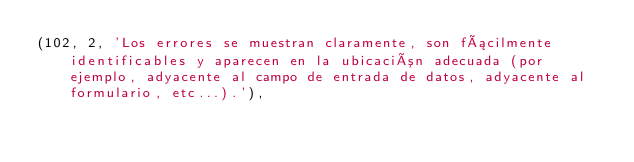Convert code to text. <code><loc_0><loc_0><loc_500><loc_500><_SQL_>(102, 2, 'Los errores se muestran claramente, son fácilmente identificables y aparecen en la ubicación adecuada (por ejemplo, adyacente al campo de entrada de datos, adyacente al formulario, etc...).'),</code> 